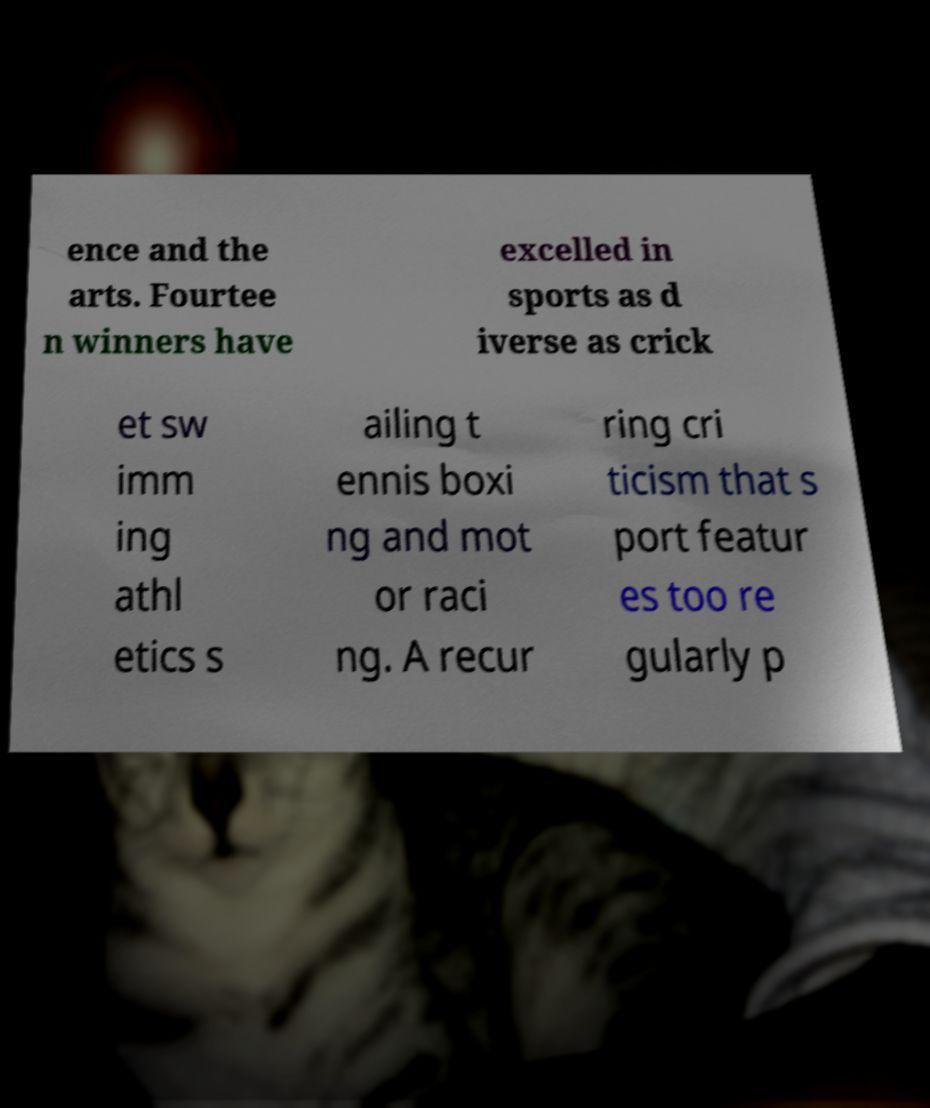Can you read and provide the text displayed in the image?This photo seems to have some interesting text. Can you extract and type it out for me? ence and the arts. Fourtee n winners have excelled in sports as d iverse as crick et sw imm ing athl etics s ailing t ennis boxi ng and mot or raci ng. A recur ring cri ticism that s port featur es too re gularly p 